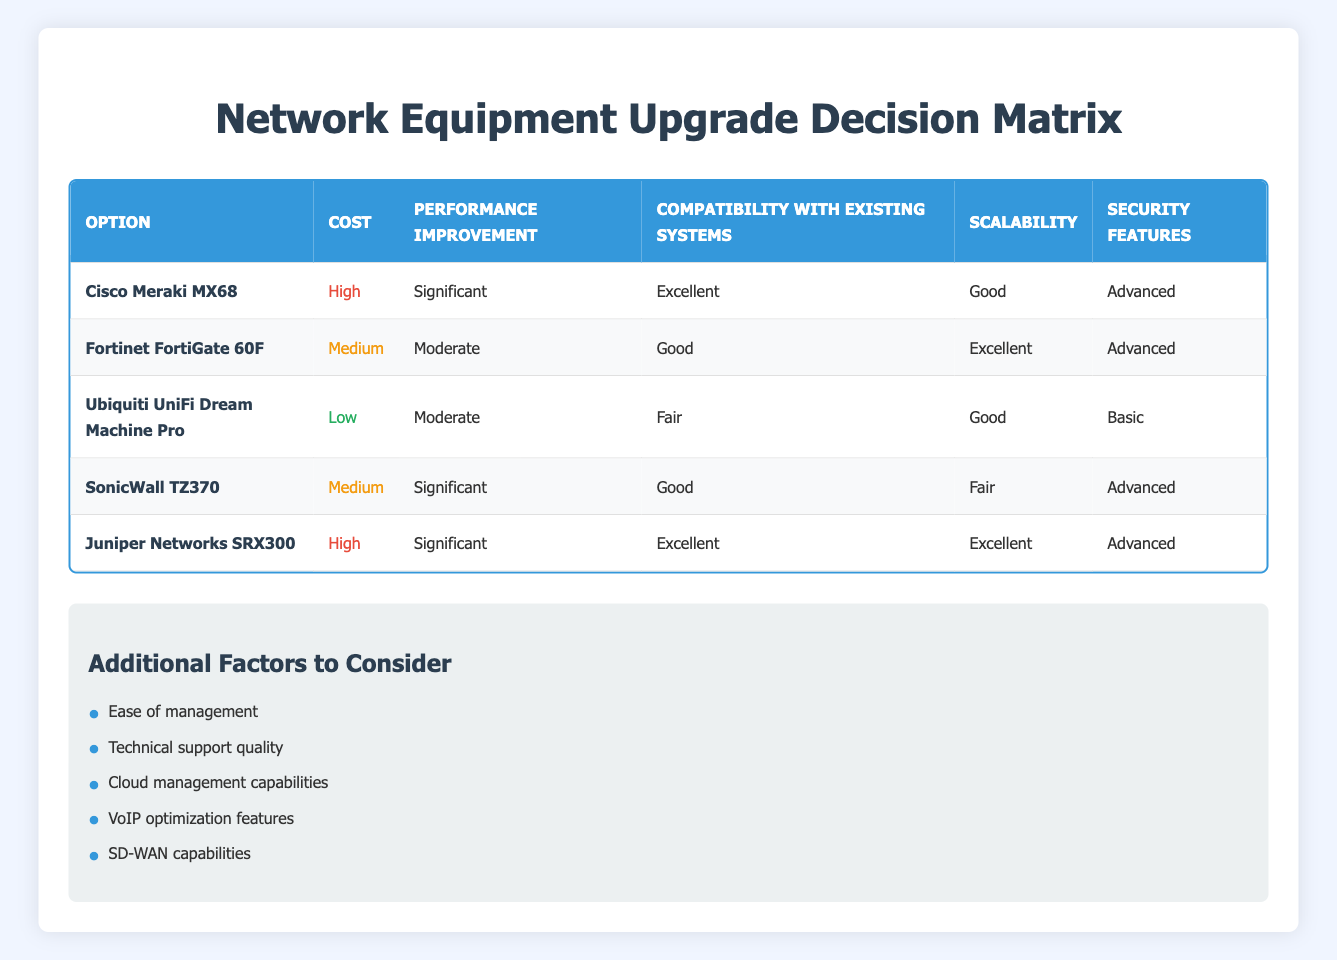What is the cost category of Cisco Meraki MX68? By looking at the row for Cisco Meraki MX68, we can directly see that the cost is listed as "High."
Answer: High Which option provides significant performance improvement? The options with "Significant" performance improvement are Cisco Meraki MX68, SonicWall TZ370, and Juniper Networks SRX300.
Answer: Cisco Meraki MX68, SonicWall TZ370, Juniper Networks SRX300 Is the Ubiquiti UniFi Dream Machine Pro compatible with existing systems? The compatibility of Ubiquiti UniFi Dream Machine Pro is rated as "Fair," indicating that it does not have strong compatibility.
Answer: No Which option has the best scalability rating? Comparing the scalability ratings across all options, Fortinet FortiGate 60F and Juniper Networks SRX300 both received an "Excellent" rating, which is the highest available.
Answer: Fortinet FortiGate 60F, Juniper Networks SRX300 What is the average cost category among all options? The options fall into three cost categories: High (Cisco Meraki MX68, Juniper Networks SRX300), Medium (Fortinet FortiGate 60F, SonicWall TZ370), and Low (Ubiquiti UniFi Dream Machine Pro). There are two high, two medium, and one low, so the average cost category is "Medium."
Answer: Medium How many options have advanced security features? The options with "Advanced" security features are Cisco Meraki MX68, Fortinet FortiGate 60F, SonicWall TZ370, and Juniper Networks SRX300—totaling four options.
Answer: Four Is the Cisco Meraki MX68 the only option rated as excellent in compatibility with existing systems? No, both Cisco Meraki MX68 and Juniper Networks SRX300 are rated as excellent in compatibility, indicating that there are two options with this rating.
Answer: No Which option has the highest cost but also excellent compatibility with existing systems? Reviewing the options, both Cisco Meraki MX68 and Juniper Networks SRX300 have high cost ratings and excellent compatibility with existing systems.
Answer: Cisco Meraki MX68, Juniper Networks SRX300 What is the performance improvement rating of SonicWall TZ370? For SonicWall TZ370, the performance improvement is marked as "Significant," indicating a substantial upgrade in performance.
Answer: Significant 